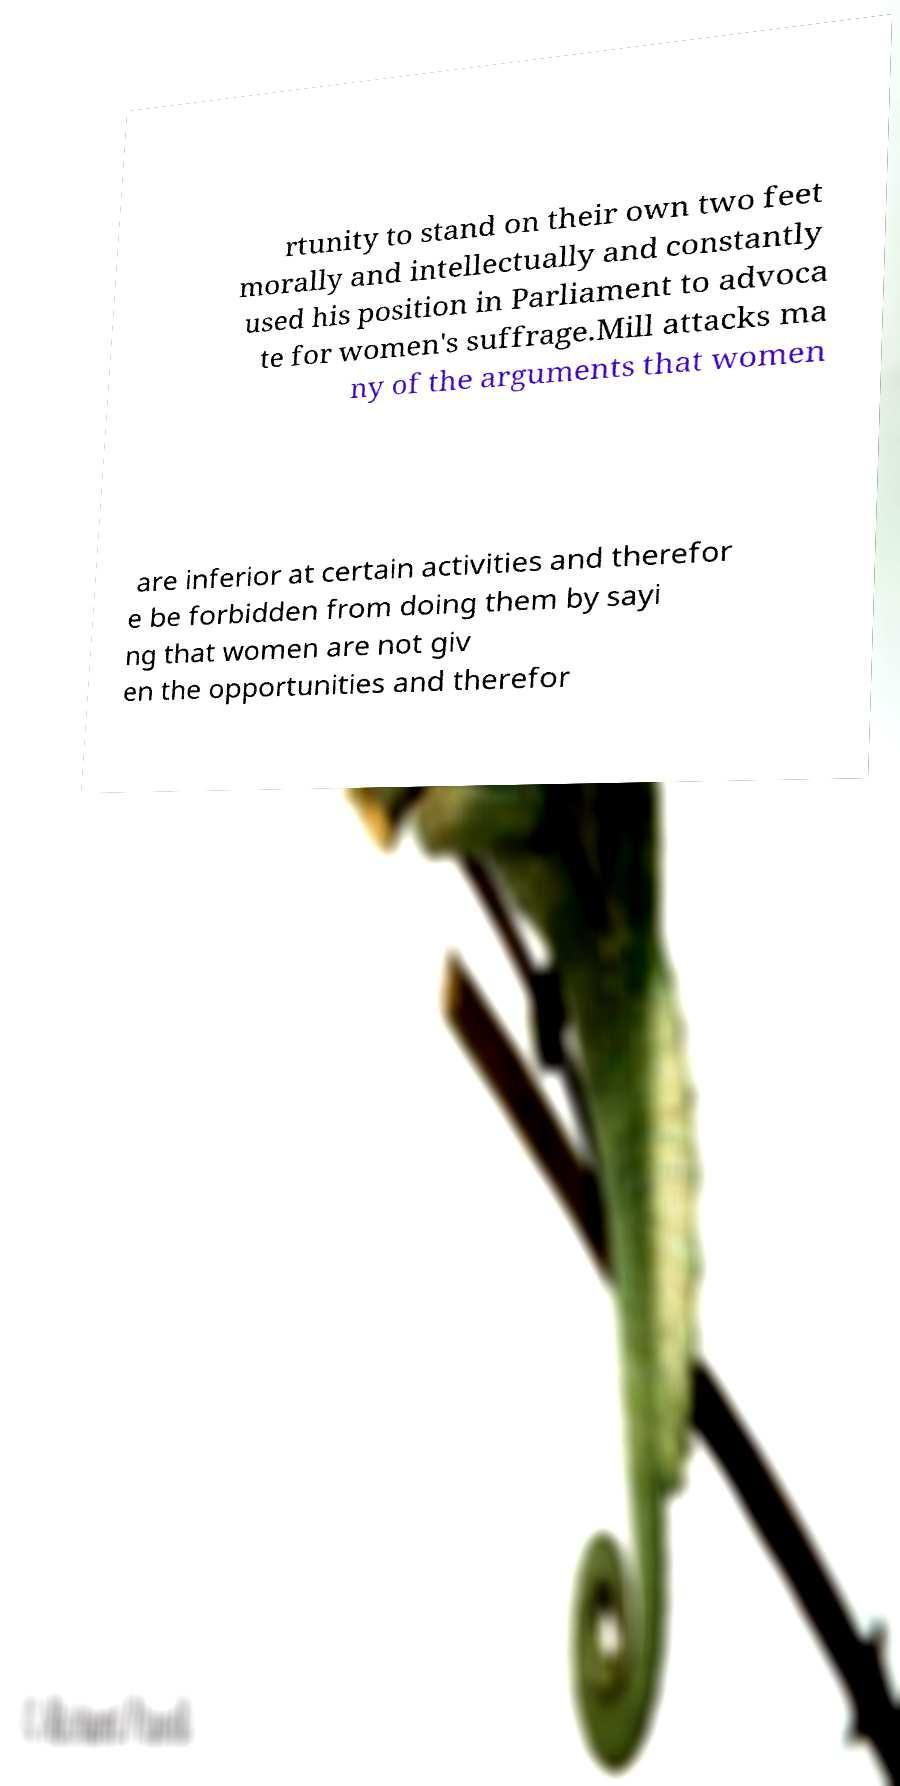Can you accurately transcribe the text from the provided image for me? rtunity to stand on their own two feet morally and intellectually and constantly used his position in Parliament to advoca te for women's suffrage.Mill attacks ma ny of the arguments that women are inferior at certain activities and therefor e be forbidden from doing them by sayi ng that women are not giv en the opportunities and therefor 